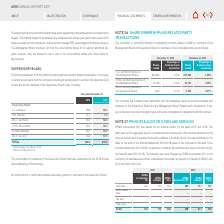According to Asm International Nv's financial document, How were the remuneration figures determined? Based on the financial document, the answer is by the 2018 Annual General Meeting of Shareholders. Also, What does the table show? information concerning all remuneration (base compensation, no bonuses or pensions were paid) from the Company (including its subsidiaries) for services in all capacities to all current and former members of the Supervisory Board of the Company. The document states: "The following table sets forth information concerning all remuneration (base compensation, no bonuses or pensions were paid) from the Company (includi..." Also, Who are the members of the Supervisory board? The document contains multiple relevant values: J.C. Lobbezoo, H.W. Kreutzer, M.C.J. van Pernis, U.H.R. Schumacher, S. Kahle-Galonske, M.J.C. de Jong. From the document: "M.J.C. de Jong 2) 34.0 57.5 M.C.J. van Pernis 56.0 58.5 S. Kahle-Galonske 55.9 60.0 H.W. Kreutzer 1) 21.4 0.0 U.H.R. Schumacher 53.5 56.0 J.C. Lobbezo..." Additionally, In 2019, who are the members that received more than 60.0 in remuneration? According to the financial document, J.C. Lobbezoo. The relevant text states: "J.C. Lobbezoo 78.6 83.5..." Additionally, For 2018, what is the order of the members arranged by ascending order in terms of remuneration? The document contains multiple relevant values: H.W. Kreutzer, M.J.C. de Jong, U.H.R. Schumacher, S. Kahle-Galonske, M.C.J. van Pernis, J.C. Lobbezoo. From the document: "M.J.C. de Jong 2) 34.0 57.5 M.C.J. van Pernis 56.0 58.5 S. Kahle-Galonske 55.9 60.0 H.W. Kreutzer 1) 21.4 0.0 U.H.R. Schumacher 53.5 56.0 J.C. Lobbezo..." Also, can you calculate: What is the percentage change in total remuneration from 2018 to 2019? To answer this question, I need to perform calculations using the financial data. The calculation is:  (315.5 - 299.4 )/ 299.4 , which equals 5.38 (percentage). This is based on the information: "TOTAL 299.4 315.5 TOTAL 299.4 315.5..." The key data points involved are: 299.4, 315.5. 